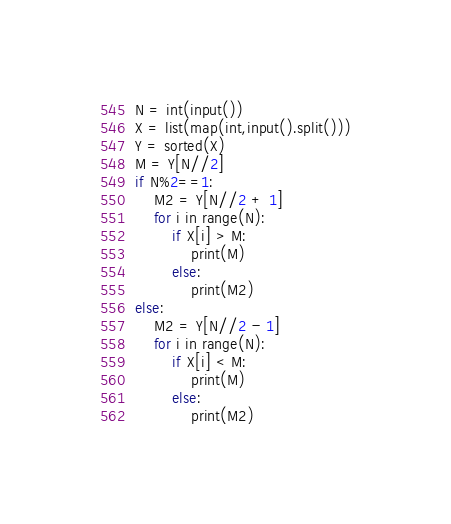Convert code to text. <code><loc_0><loc_0><loc_500><loc_500><_Python_>N = int(input())
X = list(map(int,input().split()))
Y = sorted(X)
M = Y[N//2]
if N%2==1:
    M2 = Y[N//2 + 1]
    for i in range(N):
        if X[i] > M:
            print(M)
        else:
            print(M2)
else:
    M2 = Y[N//2 - 1]
    for i in range(N):
        if X[i] < M:
            print(M)
        else:
            print(M2)</code> 